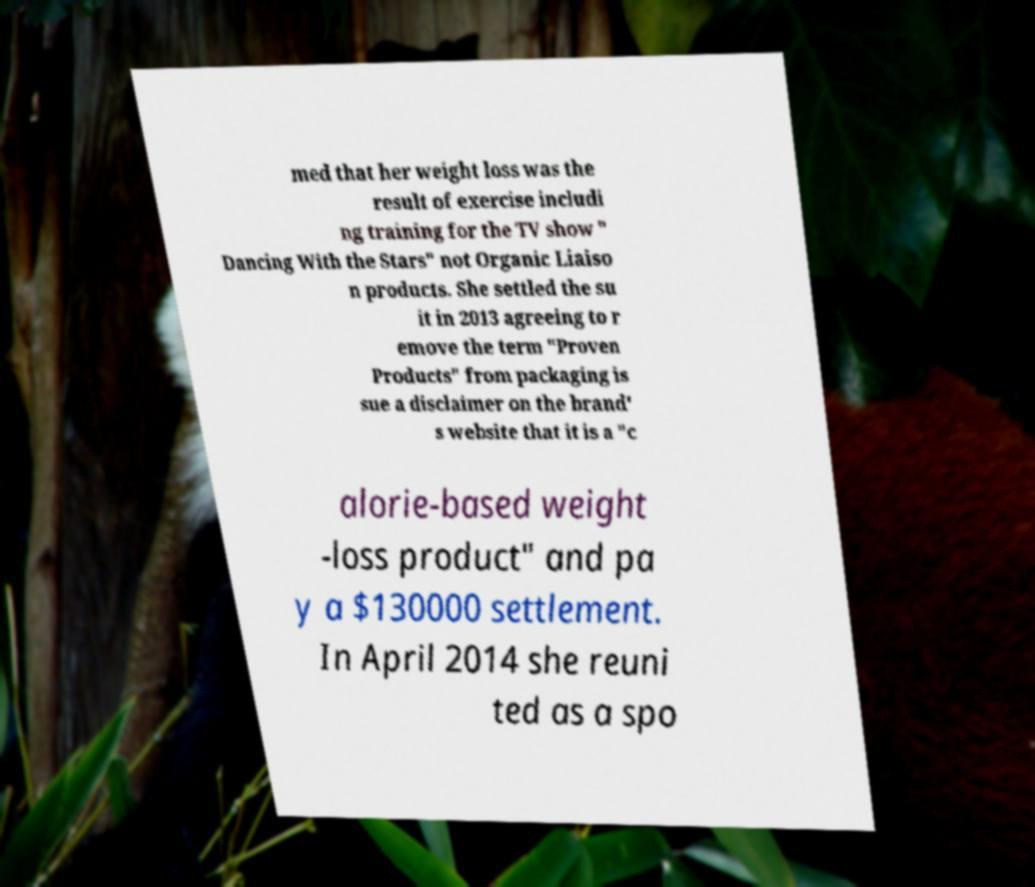Please identify and transcribe the text found in this image. med that her weight loss was the result of exercise includi ng training for the TV show " Dancing With the Stars" not Organic Liaiso n products. She settled the su it in 2013 agreeing to r emove the term "Proven Products" from packaging is sue a disclaimer on the brand' s website that it is a "c alorie-based weight -loss product" and pa y a $130000 settlement. In April 2014 she reuni ted as a spo 